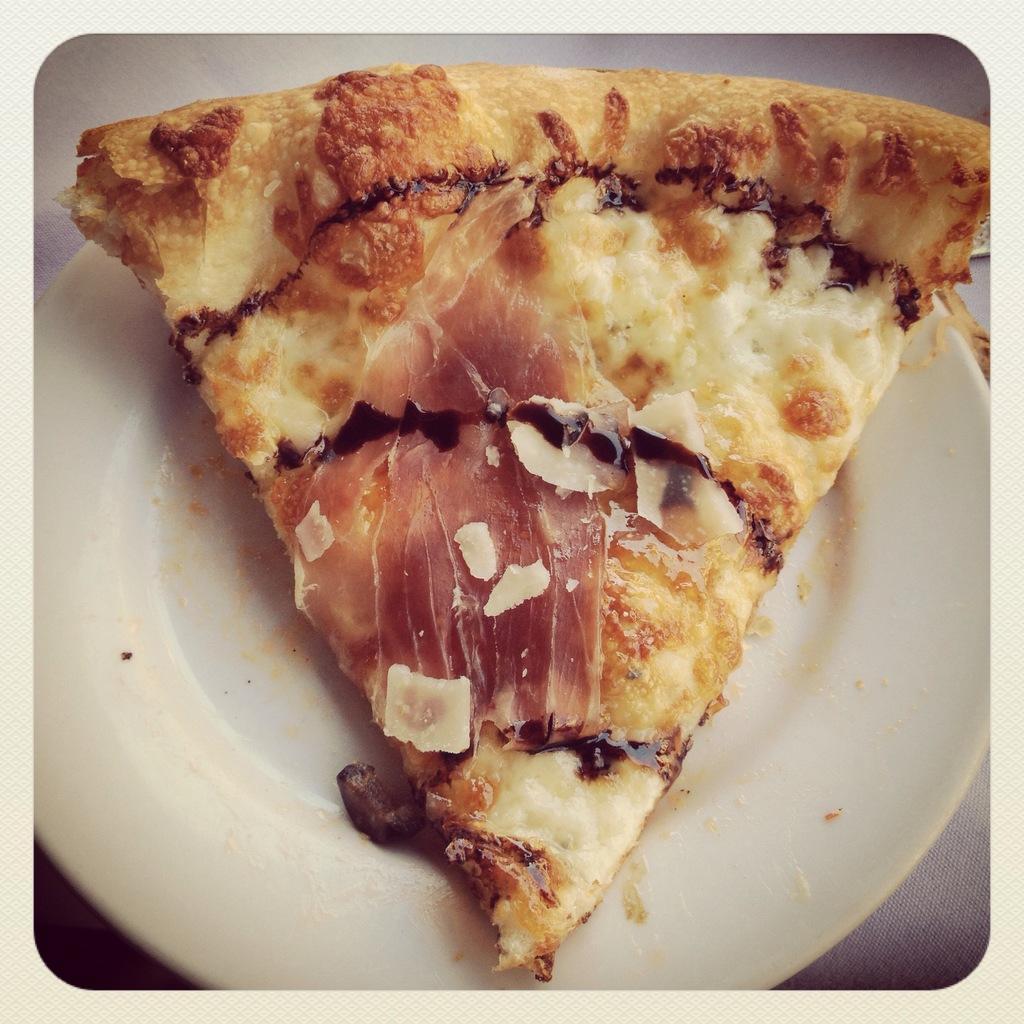Can you describe this image briefly? In this picture we can see a pizza slice in the plate. 